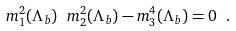Convert formula to latex. <formula><loc_0><loc_0><loc_500><loc_500>m _ { 1 } ^ { 2 } ( \Lambda _ { b } ) \ m _ { 2 } ^ { 2 } ( \Lambda _ { b } ) - m _ { 3 } ^ { 4 } ( \Lambda _ { b } ) = 0 \ .</formula> 